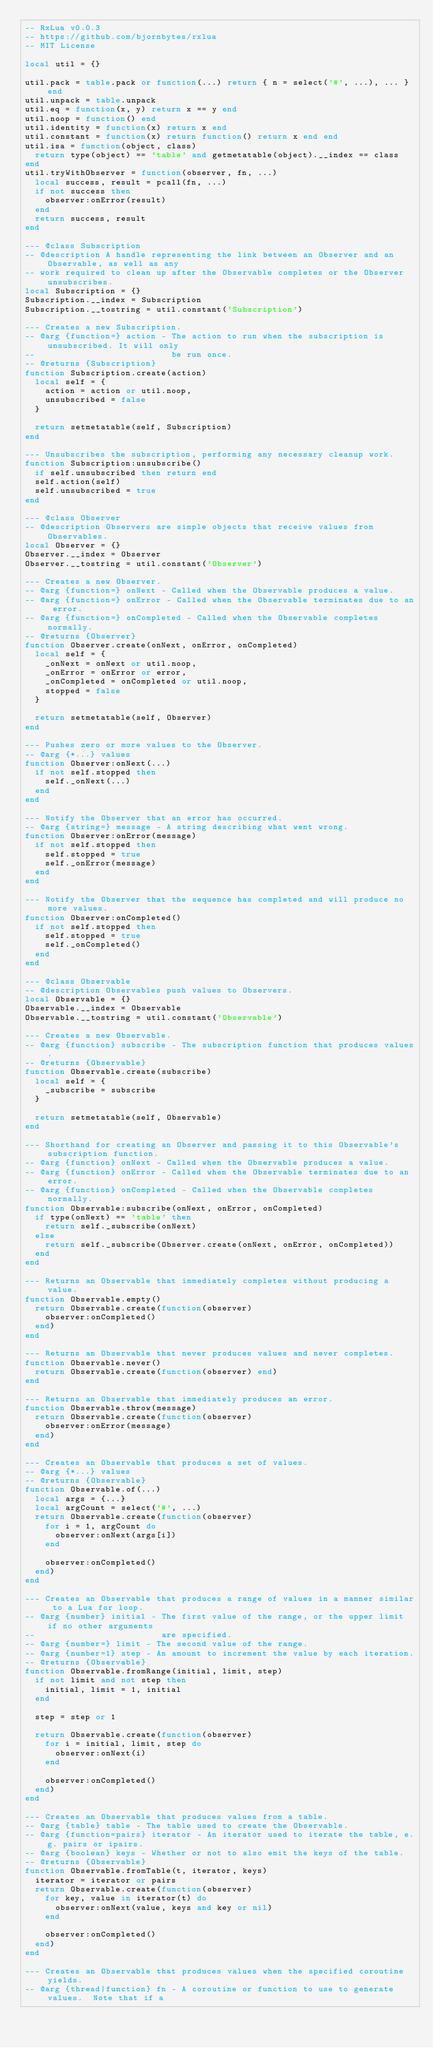Convert code to text. <code><loc_0><loc_0><loc_500><loc_500><_Lua_>-- RxLua v0.0.3
-- https://github.com/bjornbytes/rxlua
-- MIT License

local util = {}

util.pack = table.pack or function(...) return { n = select('#', ...), ... } end
util.unpack = table.unpack
util.eq = function(x, y) return x == y end
util.noop = function() end
util.identity = function(x) return x end
util.constant = function(x) return function() return x end end
util.isa = function(object, class)
  return type(object) == 'table' and getmetatable(object).__index == class
end
util.tryWithObserver = function(observer, fn, ...)
  local success, result = pcall(fn, ...)
  if not success then
    observer:onError(result)
  end
  return success, result
end

--- @class Subscription
-- @description A handle representing the link between an Observer and an Observable, as well as any
-- work required to clean up after the Observable completes or the Observer unsubscribes.
local Subscription = {}
Subscription.__index = Subscription
Subscription.__tostring = util.constant('Subscription')

--- Creates a new Subscription.
-- @arg {function=} action - The action to run when the subscription is unsubscribed. It will only
--                           be run once.
-- @returns {Subscription}
function Subscription.create(action)
  local self = {
    action = action or util.noop,
    unsubscribed = false
  }

  return setmetatable(self, Subscription)
end

--- Unsubscribes the subscription, performing any necessary cleanup work.
function Subscription:unsubscribe()
  if self.unsubscribed then return end
  self.action(self)
  self.unsubscribed = true
end

--- @class Observer
-- @description Observers are simple objects that receive values from Observables.
local Observer = {}
Observer.__index = Observer
Observer.__tostring = util.constant('Observer')

--- Creates a new Observer.
-- @arg {function=} onNext - Called when the Observable produces a value.
-- @arg {function=} onError - Called when the Observable terminates due to an error.
-- @arg {function=} onCompleted - Called when the Observable completes normally.
-- @returns {Observer}
function Observer.create(onNext, onError, onCompleted)
  local self = {
    _onNext = onNext or util.noop,
    _onError = onError or error,
    _onCompleted = onCompleted or util.noop,
    stopped = false
  }

  return setmetatable(self, Observer)
end

--- Pushes zero or more values to the Observer.
-- @arg {*...} values
function Observer:onNext(...)
  if not self.stopped then
    self._onNext(...)
  end
end

--- Notify the Observer that an error has occurred.
-- @arg {string=} message - A string describing what went wrong.
function Observer:onError(message)
  if not self.stopped then
    self.stopped = true
    self._onError(message)
  end
end

--- Notify the Observer that the sequence has completed and will produce no more values.
function Observer:onCompleted()
  if not self.stopped then
    self.stopped = true
    self._onCompleted()
  end
end

--- @class Observable
-- @description Observables push values to Observers.
local Observable = {}
Observable.__index = Observable
Observable.__tostring = util.constant('Observable')

--- Creates a new Observable.
-- @arg {function} subscribe - The subscription function that produces values.
-- @returns {Observable}
function Observable.create(subscribe)
  local self = {
    _subscribe = subscribe
  }

  return setmetatable(self, Observable)
end

--- Shorthand for creating an Observer and passing it to this Observable's subscription function.
-- @arg {function} onNext - Called when the Observable produces a value.
-- @arg {function} onError - Called when the Observable terminates due to an error.
-- @arg {function} onCompleted - Called when the Observable completes normally.
function Observable:subscribe(onNext, onError, onCompleted)
  if type(onNext) == 'table' then
    return self._subscribe(onNext)
  else
    return self._subscribe(Observer.create(onNext, onError, onCompleted))
  end
end

--- Returns an Observable that immediately completes without producing a value.
function Observable.empty()
  return Observable.create(function(observer)
    observer:onCompleted()
  end)
end

--- Returns an Observable that never produces values and never completes.
function Observable.never()
  return Observable.create(function(observer) end)
end

--- Returns an Observable that immediately produces an error.
function Observable.throw(message)
  return Observable.create(function(observer)
    observer:onError(message)
  end)
end

--- Creates an Observable that produces a set of values.
-- @arg {*...} values
-- @returns {Observable}
function Observable.of(...)
  local args = {...}
  local argCount = select('#', ...)
  return Observable.create(function(observer)
    for i = 1, argCount do
      observer:onNext(args[i])
    end

    observer:onCompleted()
  end)
end

--- Creates an Observable that produces a range of values in a manner similar to a Lua for loop.
-- @arg {number} initial - The first value of the range, or the upper limit if no other arguments
--                         are specified.
-- @arg {number=} limit - The second value of the range.
-- @arg {number=1} step - An amount to increment the value by each iteration.
-- @returns {Observable}
function Observable.fromRange(initial, limit, step)
  if not limit and not step then
    initial, limit = 1, initial
  end

  step = step or 1

  return Observable.create(function(observer)
    for i = initial, limit, step do
      observer:onNext(i)
    end

    observer:onCompleted()
  end)
end

--- Creates an Observable that produces values from a table.
-- @arg {table} table - The table used to create the Observable.
-- @arg {function=pairs} iterator - An iterator used to iterate the table, e.g. pairs or ipairs.
-- @arg {boolean} keys - Whether or not to also emit the keys of the table.
-- @returns {Observable}
function Observable.fromTable(t, iterator, keys)
  iterator = iterator or pairs
  return Observable.create(function(observer)
    for key, value in iterator(t) do
      observer:onNext(value, keys and key or nil)
    end

    observer:onCompleted()
  end)
end

--- Creates an Observable that produces values when the specified coroutine yields.
-- @arg {thread|function} fn - A coroutine or function to use to generate values.  Note that if a</code> 